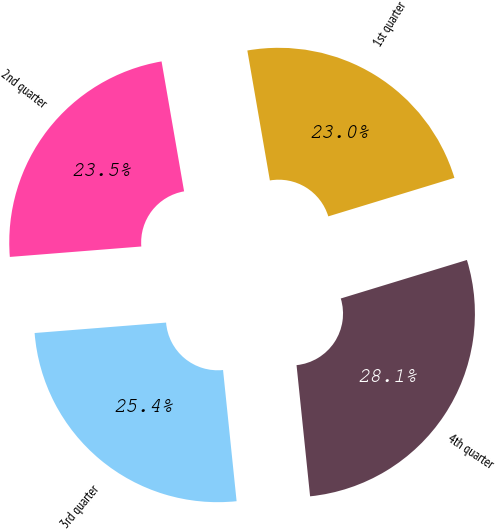<chart> <loc_0><loc_0><loc_500><loc_500><pie_chart><fcel>1st quarter<fcel>2nd quarter<fcel>3rd quarter<fcel>4th quarter<nl><fcel>23.02%<fcel>23.53%<fcel>25.38%<fcel>28.08%<nl></chart> 